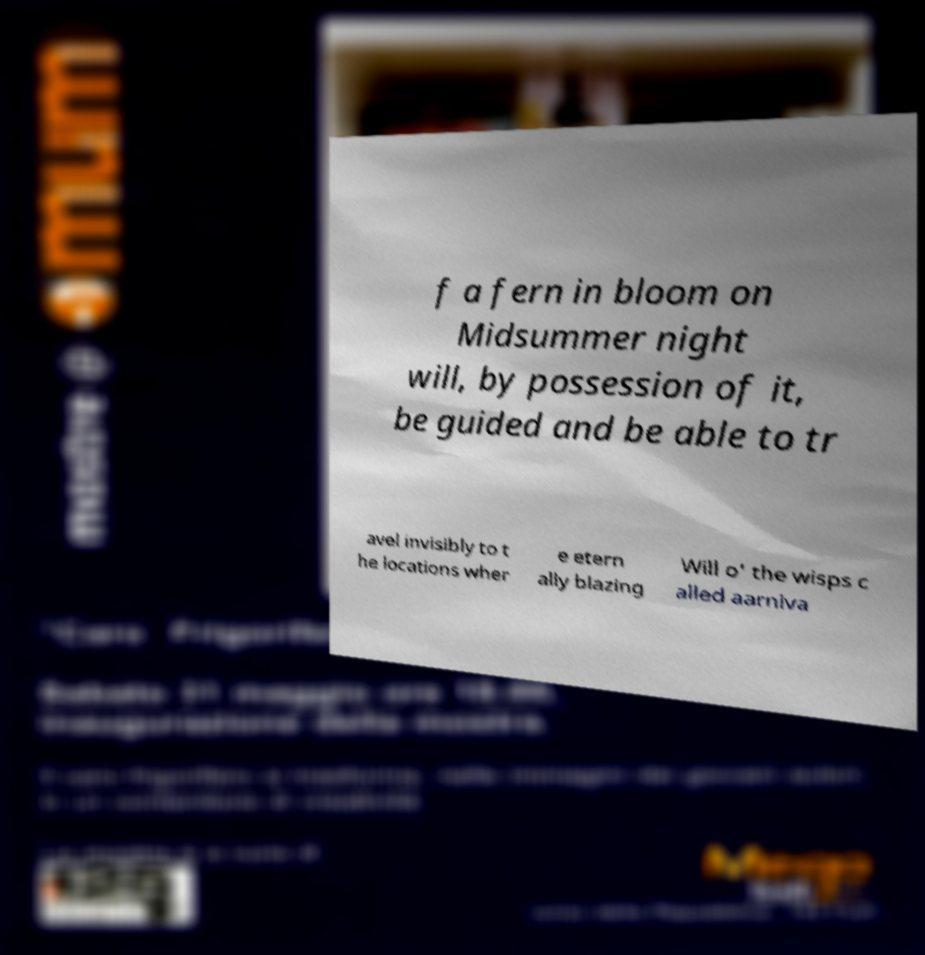Could you assist in decoding the text presented in this image and type it out clearly? f a fern in bloom on Midsummer night will, by possession of it, be guided and be able to tr avel invisibly to t he locations wher e etern ally blazing Will o' the wisps c alled aarniva 